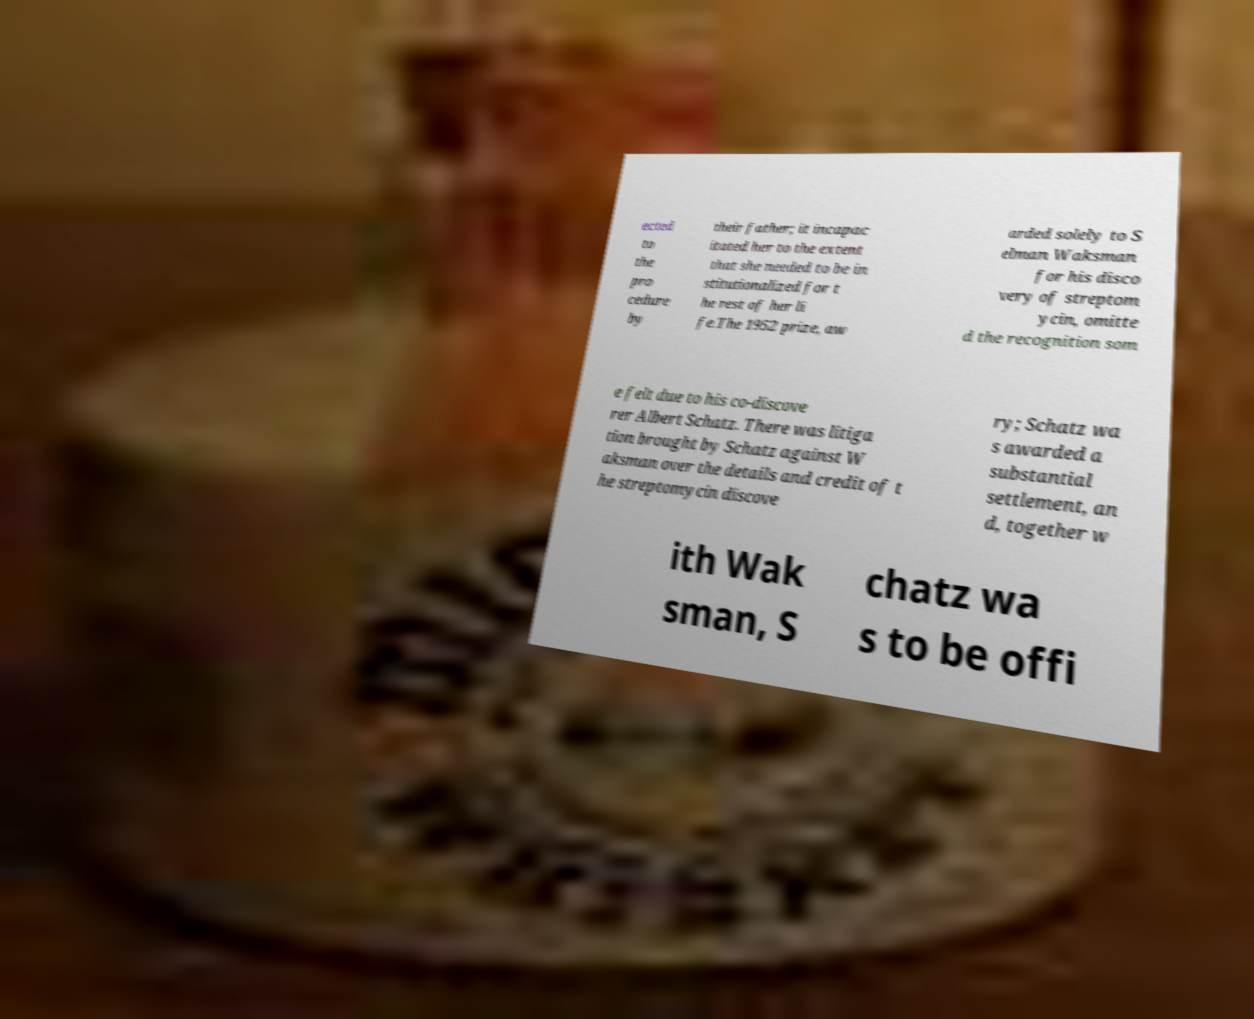Could you extract and type out the text from this image? ected to the pro cedure by their father; it incapac itated her to the extent that she needed to be in stitutionalized for t he rest of her li fe.The 1952 prize, aw arded solely to S elman Waksman for his disco very of streptom ycin, omitte d the recognition som e felt due to his co-discove rer Albert Schatz. There was litiga tion brought by Schatz against W aksman over the details and credit of t he streptomycin discove ry; Schatz wa s awarded a substantial settlement, an d, together w ith Wak sman, S chatz wa s to be offi 